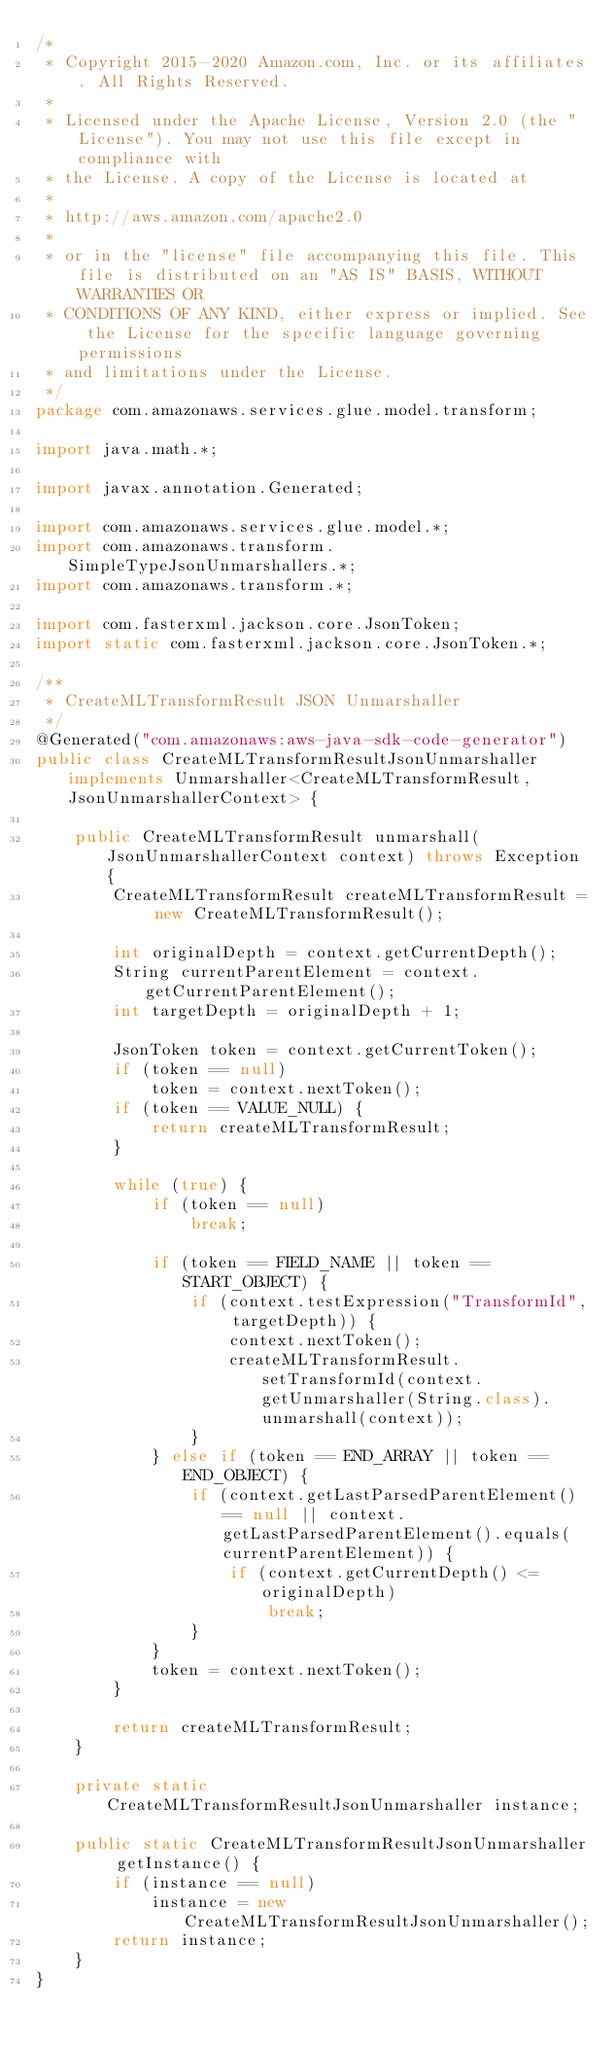Convert code to text. <code><loc_0><loc_0><loc_500><loc_500><_Java_>/*
 * Copyright 2015-2020 Amazon.com, Inc. or its affiliates. All Rights Reserved.
 * 
 * Licensed under the Apache License, Version 2.0 (the "License"). You may not use this file except in compliance with
 * the License. A copy of the License is located at
 * 
 * http://aws.amazon.com/apache2.0
 * 
 * or in the "license" file accompanying this file. This file is distributed on an "AS IS" BASIS, WITHOUT WARRANTIES OR
 * CONDITIONS OF ANY KIND, either express or implied. See the License for the specific language governing permissions
 * and limitations under the License.
 */
package com.amazonaws.services.glue.model.transform;

import java.math.*;

import javax.annotation.Generated;

import com.amazonaws.services.glue.model.*;
import com.amazonaws.transform.SimpleTypeJsonUnmarshallers.*;
import com.amazonaws.transform.*;

import com.fasterxml.jackson.core.JsonToken;
import static com.fasterxml.jackson.core.JsonToken.*;

/**
 * CreateMLTransformResult JSON Unmarshaller
 */
@Generated("com.amazonaws:aws-java-sdk-code-generator")
public class CreateMLTransformResultJsonUnmarshaller implements Unmarshaller<CreateMLTransformResult, JsonUnmarshallerContext> {

    public CreateMLTransformResult unmarshall(JsonUnmarshallerContext context) throws Exception {
        CreateMLTransformResult createMLTransformResult = new CreateMLTransformResult();

        int originalDepth = context.getCurrentDepth();
        String currentParentElement = context.getCurrentParentElement();
        int targetDepth = originalDepth + 1;

        JsonToken token = context.getCurrentToken();
        if (token == null)
            token = context.nextToken();
        if (token == VALUE_NULL) {
            return createMLTransformResult;
        }

        while (true) {
            if (token == null)
                break;

            if (token == FIELD_NAME || token == START_OBJECT) {
                if (context.testExpression("TransformId", targetDepth)) {
                    context.nextToken();
                    createMLTransformResult.setTransformId(context.getUnmarshaller(String.class).unmarshall(context));
                }
            } else if (token == END_ARRAY || token == END_OBJECT) {
                if (context.getLastParsedParentElement() == null || context.getLastParsedParentElement().equals(currentParentElement)) {
                    if (context.getCurrentDepth() <= originalDepth)
                        break;
                }
            }
            token = context.nextToken();
        }

        return createMLTransformResult;
    }

    private static CreateMLTransformResultJsonUnmarshaller instance;

    public static CreateMLTransformResultJsonUnmarshaller getInstance() {
        if (instance == null)
            instance = new CreateMLTransformResultJsonUnmarshaller();
        return instance;
    }
}
</code> 